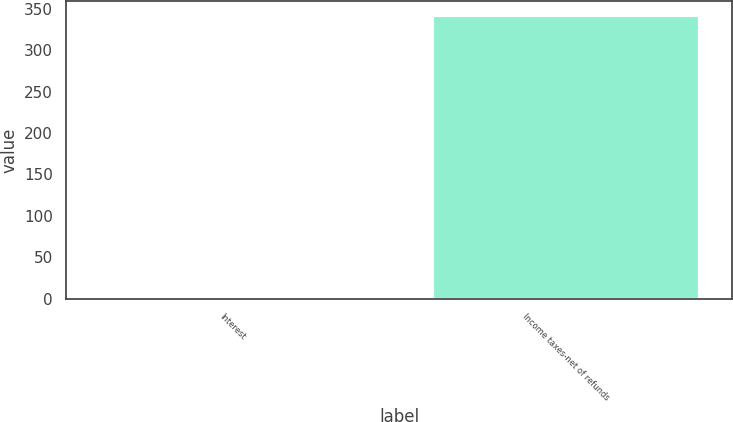<chart> <loc_0><loc_0><loc_500><loc_500><bar_chart><fcel>Interest<fcel>Income taxes-net of refunds<nl><fcel>1.2<fcel>342.3<nl></chart> 